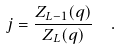<formula> <loc_0><loc_0><loc_500><loc_500>j & = \frac { Z _ { L - 1 } ( q ) } { Z _ { L } ( q ) } \quad .</formula> 